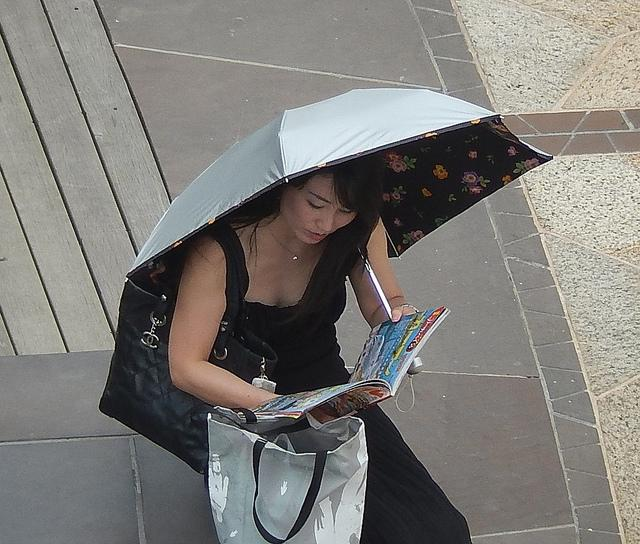What does the lady use the umbrella for?

Choices:
A) hail
B) rain
C) wind
D) shade shade 